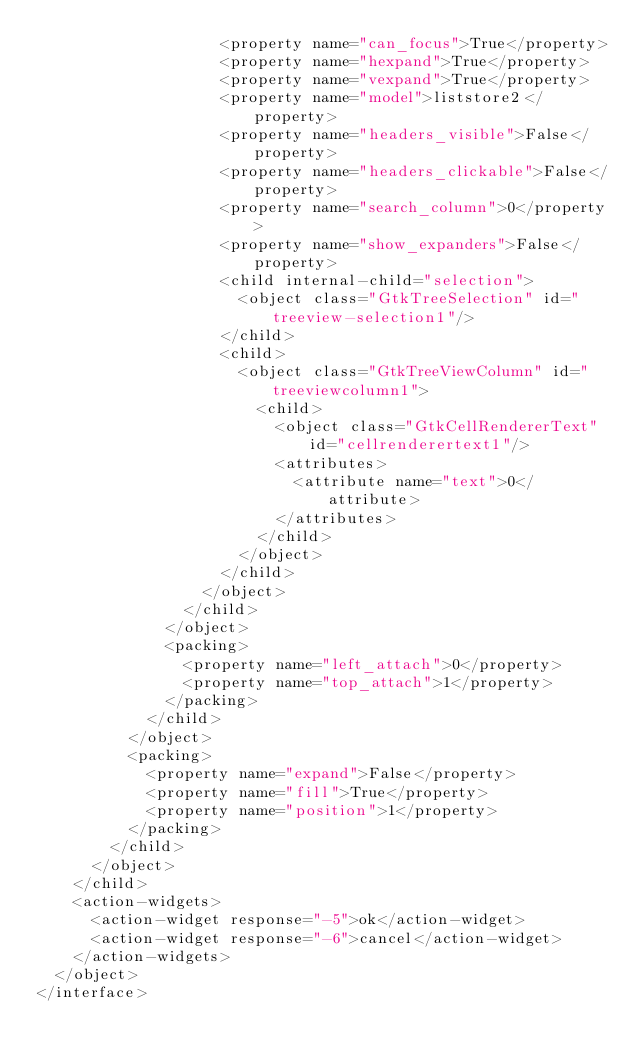<code> <loc_0><loc_0><loc_500><loc_500><_XML_>                    <property name="can_focus">True</property>
                    <property name="hexpand">True</property>
                    <property name="vexpand">True</property>
                    <property name="model">liststore2</property>
                    <property name="headers_visible">False</property>
                    <property name="headers_clickable">False</property>
                    <property name="search_column">0</property>
                    <property name="show_expanders">False</property>
                    <child internal-child="selection">
                      <object class="GtkTreeSelection" id="treeview-selection1"/>
                    </child>
                    <child>
                      <object class="GtkTreeViewColumn" id="treeviewcolumn1">
                        <child>
                          <object class="GtkCellRendererText" id="cellrenderertext1"/>
                          <attributes>
                            <attribute name="text">0</attribute>
                          </attributes>
                        </child>
                      </object>
                    </child>
                  </object>
                </child>
              </object>
              <packing>
                <property name="left_attach">0</property>
                <property name="top_attach">1</property>
              </packing>
            </child>
          </object>
          <packing>
            <property name="expand">False</property>
            <property name="fill">True</property>
            <property name="position">1</property>
          </packing>
        </child>
      </object>
    </child>
    <action-widgets>
      <action-widget response="-5">ok</action-widget>
      <action-widget response="-6">cancel</action-widget>
    </action-widgets>
  </object>
</interface>
</code> 